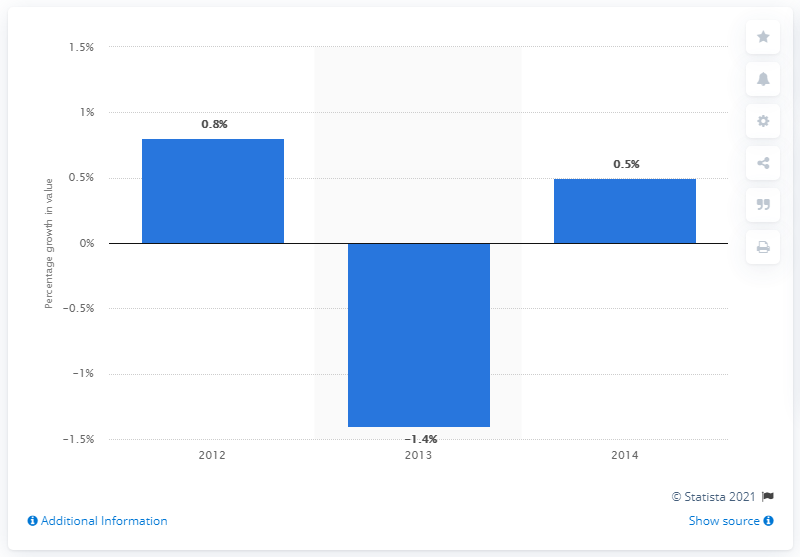Identify some key points in this picture. In 2014, the European cosmetics market experienced significant growth, reaching 0.5%. 